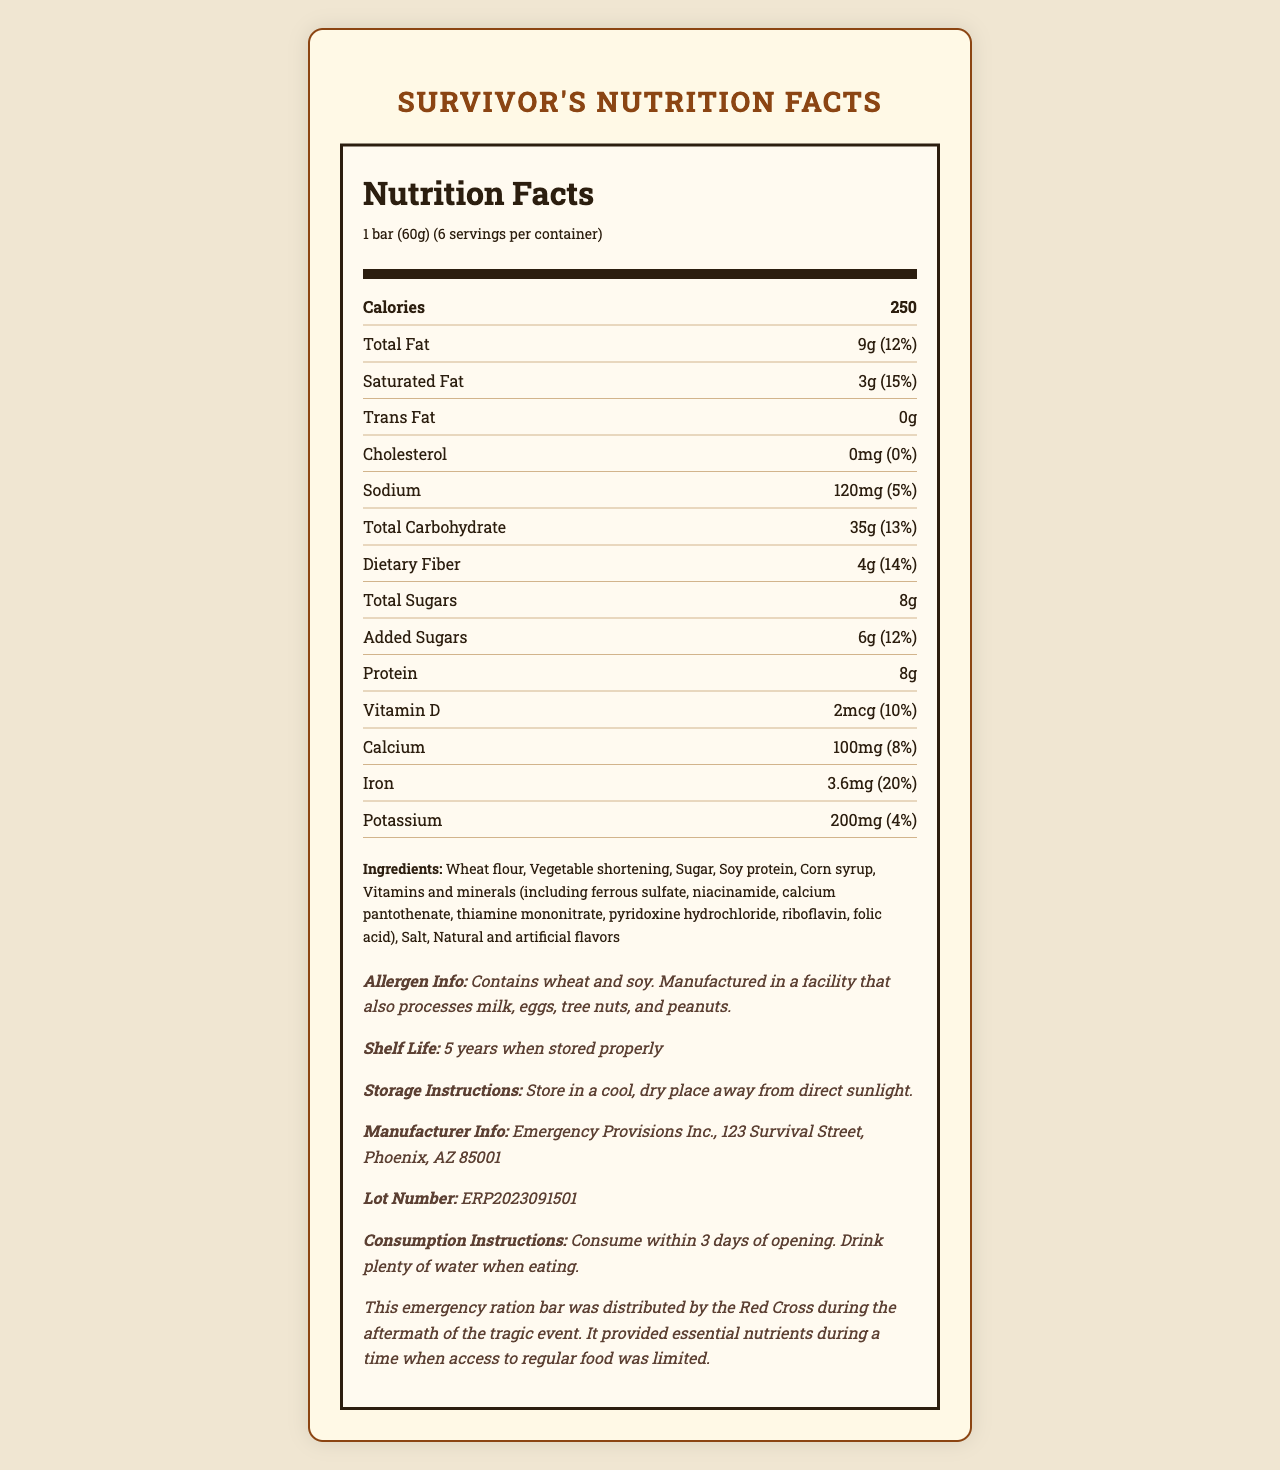what is the serving size? The serving size is stated as "1 bar (60g)" under the Nutrition Facts section.
Answer: 1 bar (60g) how many calories are there per serving? The calories per serving are listed as 250 in the Nutrition Facts section.
Answer: 250 how many servings are there per container? The document states that there are 6 servings per container.
Answer: 6 what is the total fat content per serving? The total fat content per serving is listed as 9g in the document.
Answer: 9g what percentage of the daily value of saturated fat does one serving provide? The document specifies that one serving provides 15% of the daily value of saturated fat.
Answer: 15% what is the total carbohydrate amount per serving? The total carbohydrate amount per serving is listed as 35g in the document.
Answer: 35g does the product contain any cholesterol? The document mentions that the product contains 0mg of cholesterol, which is 0% of the daily value.
Answer: No how much dietary fiber does one serving provide? One serving provides 4g of dietary fiber according to the document.
Answer: 4g does the product contain any trans fat? The document states that the product contains 0g of trans fat.
Answer: No how many grams of protein are in each serving? Each serving contains 8g of protein according to the Nutrition Facts section.
Answer: 8g what is the shelf life of the product? The shelf life is mentioned as "5 years when stored properly."
Answer: 5 years what is the sodium content per serving? The sodium content per serving is listed as 120mg in the document.
Answer: 120mg what are the storage instructions for this product? A. Store in a refrigerator B. Store at room temperature C. Store in a cool, dry place D. Store in a warm place The storage instructions state to "Store in a cool, dry place away from direct sunlight."
Answer: C which of the following ingredients are found in this emergency ration bar? I. Wheat flour II. Corn syrup III. Milk IV. Sugar The document lists wheat flour, corn syrup, and sugar as ingredients but does not mention milk.
Answer: I, II, IV does this product contain allergens? The allergen information states that it contains wheat and soy and is manufactured in a facility that processes milk, eggs, tree nuts, and peanuts.
Answer: Yes what is the main purpose of this document? The document provides detailed nutritional facts, ingredients, allergen information, storage instructions, and other relevant information about the SurviveWell Emergency Ration Bar.
Answer: To provide nutritional information and details about the SurviveWell Emergency Ration Bar how much vitamin D is in each serving? Each serving contains 2mcg of Vitamin D according to the document.
Answer: 2mcg what percentage of daily value of iron does one serving provide? One serving provides 20% of the daily value of iron as mentioned in the document.
Answer: 20% what is the manufacturer's name and address? The manufacturer is listed as Emergency Provisions Inc. with the address at 123 Survival Street, Phoenix, AZ 85001.
Answer: Emergency Provisions Inc., 123 Survival Street, Phoenix, AZ 85001 how many grams of added sugars are in each serving? The added sugars amount is listed as 6g per serving in the Nutrition Facts section.
Answer: 6g what is the lot number of this product? The document mentions the lot number as ERP2023091501.
Answer: ERP2023091501 what other products are manufactured by the same facility? The document does not provide information about other products manufactured by the same facility.
Answer: Cannot be determined 